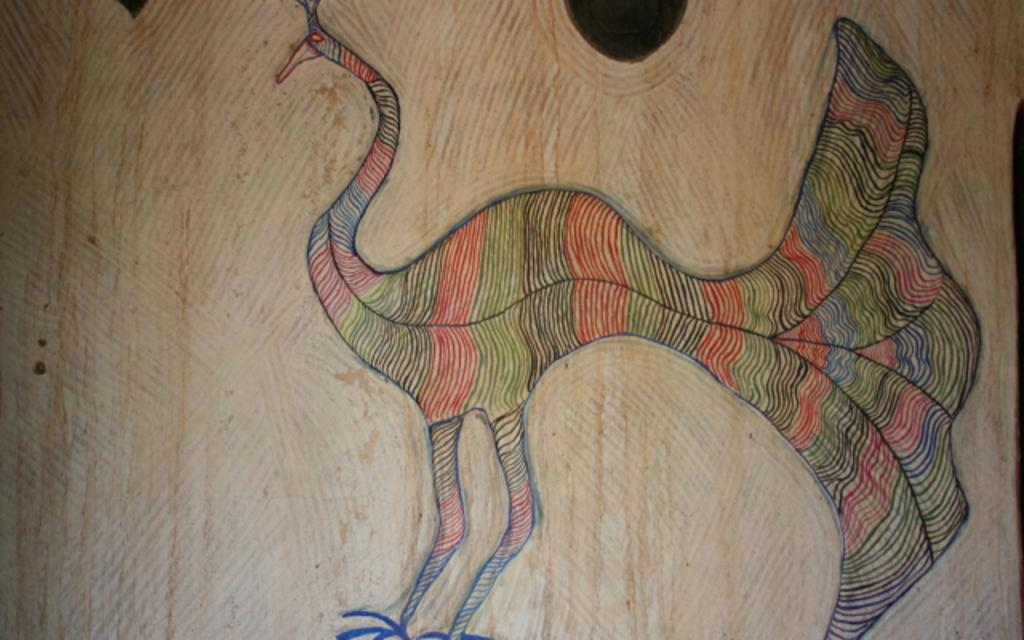What is the main subject of the image? There is a drawing in the center of the image. What type of carriage is depicted in the drawing? There is no carriage present in the drawing; it only features a drawing in the center of the image. What class of students can be seen studying in the image? There is no reference to students or a classroom in the image, so it is not possible to determine the class of students. 